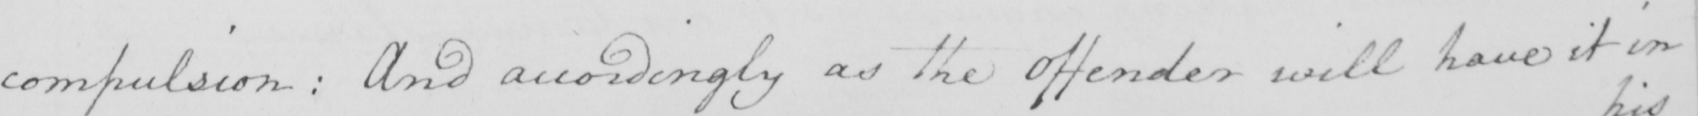Please transcribe the handwritten text in this image. compulsion :  And accordingly as the Offender will have it in 